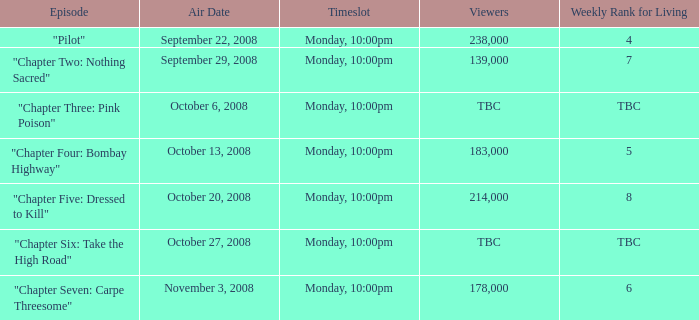What is the number of viewers for the episode with a weekly living rank of 4? 238000.0. 